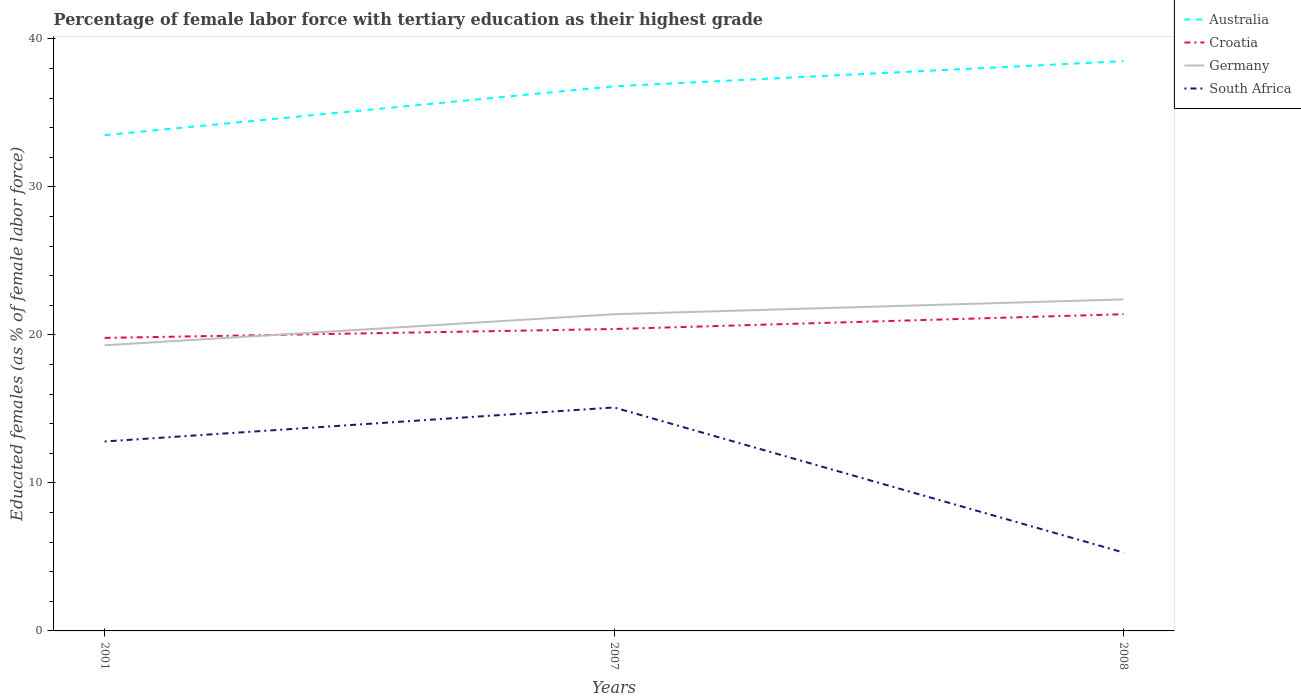Does the line corresponding to Germany intersect with the line corresponding to Croatia?
Your answer should be very brief. Yes. Across all years, what is the maximum percentage of female labor force with tertiary education in South Africa?
Keep it short and to the point. 5.3. What is the total percentage of female labor force with tertiary education in Croatia in the graph?
Provide a short and direct response. -1. What is the difference between the highest and the second highest percentage of female labor force with tertiary education in Australia?
Keep it short and to the point. 5. How many lines are there?
Make the answer very short. 4. How many years are there in the graph?
Provide a succinct answer. 3. What is the difference between two consecutive major ticks on the Y-axis?
Your answer should be compact. 10. Are the values on the major ticks of Y-axis written in scientific E-notation?
Make the answer very short. No. Does the graph contain grids?
Offer a very short reply. No. Where does the legend appear in the graph?
Your answer should be very brief. Top right. How many legend labels are there?
Your answer should be very brief. 4. How are the legend labels stacked?
Your response must be concise. Vertical. What is the title of the graph?
Ensure brevity in your answer.  Percentage of female labor force with tertiary education as their highest grade. Does "High income: OECD" appear as one of the legend labels in the graph?
Make the answer very short. No. What is the label or title of the Y-axis?
Your answer should be very brief. Educated females (as % of female labor force). What is the Educated females (as % of female labor force) of Australia in 2001?
Make the answer very short. 33.5. What is the Educated females (as % of female labor force) of Croatia in 2001?
Provide a succinct answer. 19.8. What is the Educated females (as % of female labor force) in Germany in 2001?
Ensure brevity in your answer.  19.3. What is the Educated females (as % of female labor force) of South Africa in 2001?
Ensure brevity in your answer.  12.8. What is the Educated females (as % of female labor force) in Australia in 2007?
Keep it short and to the point. 36.8. What is the Educated females (as % of female labor force) in Croatia in 2007?
Your response must be concise. 20.4. What is the Educated females (as % of female labor force) of Germany in 2007?
Your response must be concise. 21.4. What is the Educated females (as % of female labor force) in South Africa in 2007?
Make the answer very short. 15.1. What is the Educated females (as % of female labor force) in Australia in 2008?
Your answer should be compact. 38.5. What is the Educated females (as % of female labor force) in Croatia in 2008?
Give a very brief answer. 21.4. What is the Educated females (as % of female labor force) of Germany in 2008?
Your answer should be compact. 22.4. What is the Educated females (as % of female labor force) in South Africa in 2008?
Offer a terse response. 5.3. Across all years, what is the maximum Educated females (as % of female labor force) of Australia?
Offer a very short reply. 38.5. Across all years, what is the maximum Educated females (as % of female labor force) in Croatia?
Provide a succinct answer. 21.4. Across all years, what is the maximum Educated females (as % of female labor force) of Germany?
Your answer should be very brief. 22.4. Across all years, what is the maximum Educated females (as % of female labor force) in South Africa?
Offer a very short reply. 15.1. Across all years, what is the minimum Educated females (as % of female labor force) in Australia?
Give a very brief answer. 33.5. Across all years, what is the minimum Educated females (as % of female labor force) of Croatia?
Ensure brevity in your answer.  19.8. Across all years, what is the minimum Educated females (as % of female labor force) of Germany?
Your response must be concise. 19.3. Across all years, what is the minimum Educated females (as % of female labor force) of South Africa?
Give a very brief answer. 5.3. What is the total Educated females (as % of female labor force) in Australia in the graph?
Provide a short and direct response. 108.8. What is the total Educated females (as % of female labor force) in Croatia in the graph?
Keep it short and to the point. 61.6. What is the total Educated females (as % of female labor force) of Germany in the graph?
Give a very brief answer. 63.1. What is the total Educated females (as % of female labor force) of South Africa in the graph?
Offer a terse response. 33.2. What is the difference between the Educated females (as % of female labor force) in Germany in 2001 and that in 2007?
Your answer should be compact. -2.1. What is the difference between the Educated females (as % of female labor force) in Croatia in 2001 and that in 2008?
Your response must be concise. -1.6. What is the difference between the Educated females (as % of female labor force) of South Africa in 2001 and that in 2008?
Your answer should be compact. 7.5. What is the difference between the Educated females (as % of female labor force) of Australia in 2007 and that in 2008?
Ensure brevity in your answer.  -1.7. What is the difference between the Educated females (as % of female labor force) of South Africa in 2007 and that in 2008?
Keep it short and to the point. 9.8. What is the difference between the Educated females (as % of female labor force) of Australia in 2001 and the Educated females (as % of female labor force) of Croatia in 2007?
Your answer should be very brief. 13.1. What is the difference between the Educated females (as % of female labor force) of Australia in 2001 and the Educated females (as % of female labor force) of Germany in 2007?
Keep it short and to the point. 12.1. What is the difference between the Educated females (as % of female labor force) of Australia in 2001 and the Educated females (as % of female labor force) of Germany in 2008?
Provide a short and direct response. 11.1. What is the difference between the Educated females (as % of female labor force) in Australia in 2001 and the Educated females (as % of female labor force) in South Africa in 2008?
Keep it short and to the point. 28.2. What is the difference between the Educated females (as % of female labor force) in Croatia in 2001 and the Educated females (as % of female labor force) in Germany in 2008?
Provide a short and direct response. -2.6. What is the difference between the Educated females (as % of female labor force) in Croatia in 2001 and the Educated females (as % of female labor force) in South Africa in 2008?
Your response must be concise. 14.5. What is the difference between the Educated females (as % of female labor force) in Germany in 2001 and the Educated females (as % of female labor force) in South Africa in 2008?
Make the answer very short. 14. What is the difference between the Educated females (as % of female labor force) of Australia in 2007 and the Educated females (as % of female labor force) of Croatia in 2008?
Offer a terse response. 15.4. What is the difference between the Educated females (as % of female labor force) in Australia in 2007 and the Educated females (as % of female labor force) in Germany in 2008?
Your answer should be very brief. 14.4. What is the difference between the Educated females (as % of female labor force) of Australia in 2007 and the Educated females (as % of female labor force) of South Africa in 2008?
Give a very brief answer. 31.5. What is the average Educated females (as % of female labor force) in Australia per year?
Offer a terse response. 36.27. What is the average Educated females (as % of female labor force) in Croatia per year?
Give a very brief answer. 20.53. What is the average Educated females (as % of female labor force) in Germany per year?
Provide a short and direct response. 21.03. What is the average Educated females (as % of female labor force) in South Africa per year?
Your answer should be very brief. 11.07. In the year 2001, what is the difference between the Educated females (as % of female labor force) in Australia and Educated females (as % of female labor force) in Croatia?
Make the answer very short. 13.7. In the year 2001, what is the difference between the Educated females (as % of female labor force) in Australia and Educated females (as % of female labor force) in South Africa?
Your response must be concise. 20.7. In the year 2001, what is the difference between the Educated females (as % of female labor force) of Croatia and Educated females (as % of female labor force) of South Africa?
Your answer should be very brief. 7. In the year 2001, what is the difference between the Educated females (as % of female labor force) in Germany and Educated females (as % of female labor force) in South Africa?
Make the answer very short. 6.5. In the year 2007, what is the difference between the Educated females (as % of female labor force) in Australia and Educated females (as % of female labor force) in South Africa?
Offer a very short reply. 21.7. In the year 2007, what is the difference between the Educated females (as % of female labor force) in Germany and Educated females (as % of female labor force) in South Africa?
Offer a terse response. 6.3. In the year 2008, what is the difference between the Educated females (as % of female labor force) of Australia and Educated females (as % of female labor force) of Croatia?
Make the answer very short. 17.1. In the year 2008, what is the difference between the Educated females (as % of female labor force) of Australia and Educated females (as % of female labor force) of Germany?
Your answer should be compact. 16.1. In the year 2008, what is the difference between the Educated females (as % of female labor force) of Australia and Educated females (as % of female labor force) of South Africa?
Offer a terse response. 33.2. In the year 2008, what is the difference between the Educated females (as % of female labor force) of Croatia and Educated females (as % of female labor force) of Germany?
Ensure brevity in your answer.  -1. In the year 2008, what is the difference between the Educated females (as % of female labor force) in Croatia and Educated females (as % of female labor force) in South Africa?
Give a very brief answer. 16.1. What is the ratio of the Educated females (as % of female labor force) in Australia in 2001 to that in 2007?
Ensure brevity in your answer.  0.91. What is the ratio of the Educated females (as % of female labor force) of Croatia in 2001 to that in 2007?
Offer a very short reply. 0.97. What is the ratio of the Educated females (as % of female labor force) in Germany in 2001 to that in 2007?
Ensure brevity in your answer.  0.9. What is the ratio of the Educated females (as % of female labor force) of South Africa in 2001 to that in 2007?
Provide a short and direct response. 0.85. What is the ratio of the Educated females (as % of female labor force) in Australia in 2001 to that in 2008?
Offer a terse response. 0.87. What is the ratio of the Educated females (as % of female labor force) of Croatia in 2001 to that in 2008?
Ensure brevity in your answer.  0.93. What is the ratio of the Educated females (as % of female labor force) of Germany in 2001 to that in 2008?
Your answer should be compact. 0.86. What is the ratio of the Educated females (as % of female labor force) of South Africa in 2001 to that in 2008?
Provide a short and direct response. 2.42. What is the ratio of the Educated females (as % of female labor force) in Australia in 2007 to that in 2008?
Give a very brief answer. 0.96. What is the ratio of the Educated females (as % of female labor force) in Croatia in 2007 to that in 2008?
Offer a terse response. 0.95. What is the ratio of the Educated females (as % of female labor force) in Germany in 2007 to that in 2008?
Make the answer very short. 0.96. What is the ratio of the Educated females (as % of female labor force) in South Africa in 2007 to that in 2008?
Your answer should be compact. 2.85. What is the difference between the highest and the second highest Educated females (as % of female labor force) of Australia?
Your response must be concise. 1.7. What is the difference between the highest and the second highest Educated females (as % of female labor force) of Croatia?
Your response must be concise. 1. What is the difference between the highest and the lowest Educated females (as % of female labor force) of Australia?
Your answer should be very brief. 5. What is the difference between the highest and the lowest Educated females (as % of female labor force) in Germany?
Offer a very short reply. 3.1. 